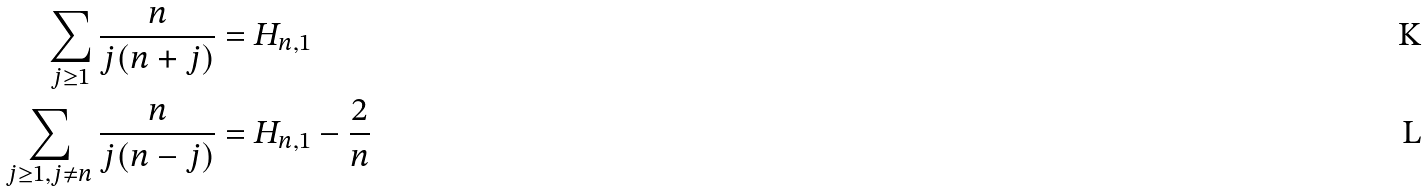Convert formula to latex. <formula><loc_0><loc_0><loc_500><loc_500>\sum _ { j \geq 1 } \frac { n } { j ( n + j ) } & = H _ { n , 1 } \\ \sum _ { j \geq 1 , j \neq n } \frac { n } { j ( n - j ) } & = H _ { n , 1 } - \frac { 2 } { n }</formula> 